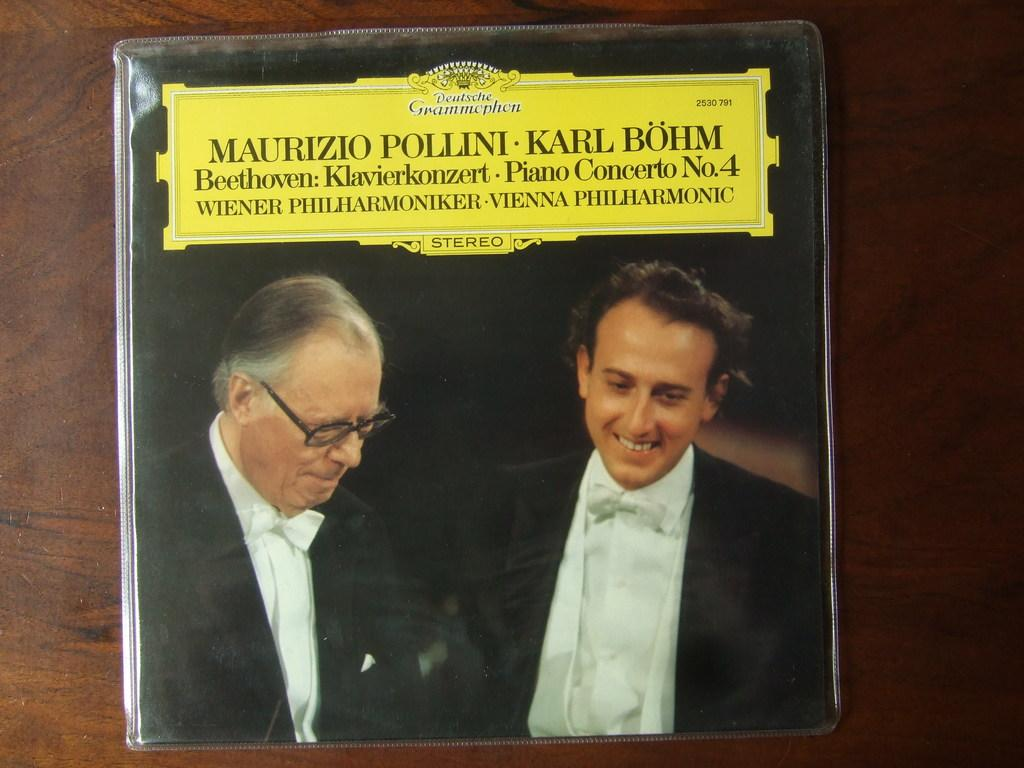What is the main subject of the image? The main subject of the image is a photo of two persons. What else can be seen in the image besides the photo? There is text on the floor in the image. Where was the image likely taken? The image appears to be taken in a room. What type of cover is protecting the stone in the image? There is no stone or cover present in the image. 